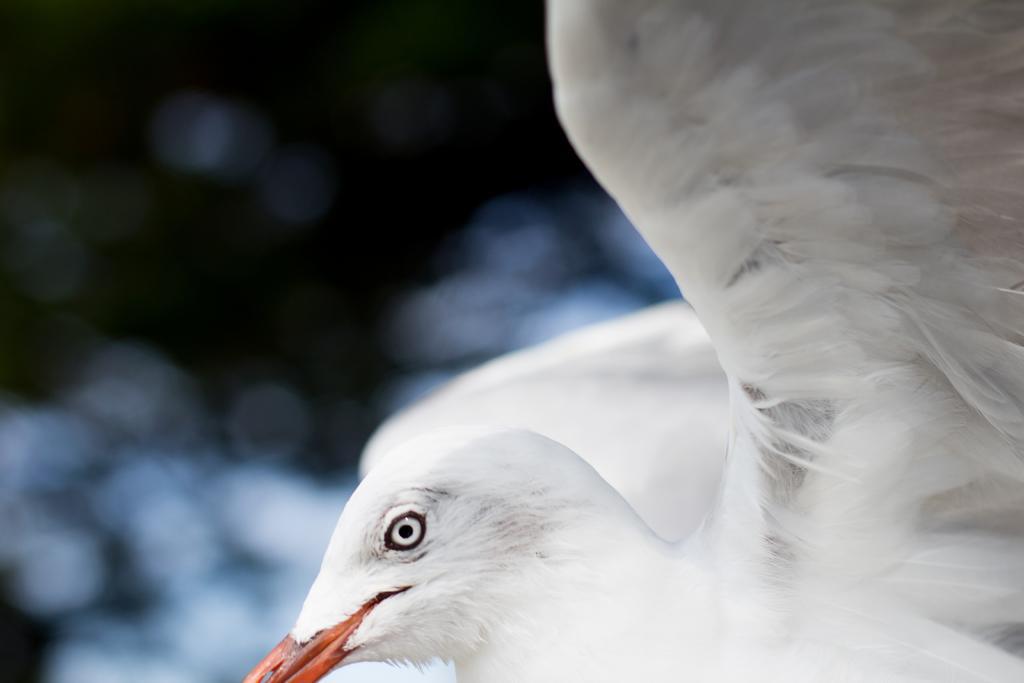How would you summarize this image in a sentence or two? In this image I can see a white color bird and I can see this image is blurry from background. 